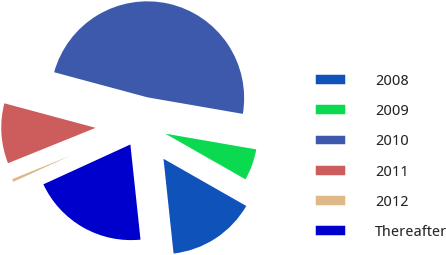Convert chart. <chart><loc_0><loc_0><loc_500><loc_500><pie_chart><fcel>2008<fcel>2009<fcel>2010<fcel>2011<fcel>2012<fcel>Thereafter<nl><fcel>15.07%<fcel>5.51%<fcel>48.55%<fcel>10.29%<fcel>0.73%<fcel>19.85%<nl></chart> 